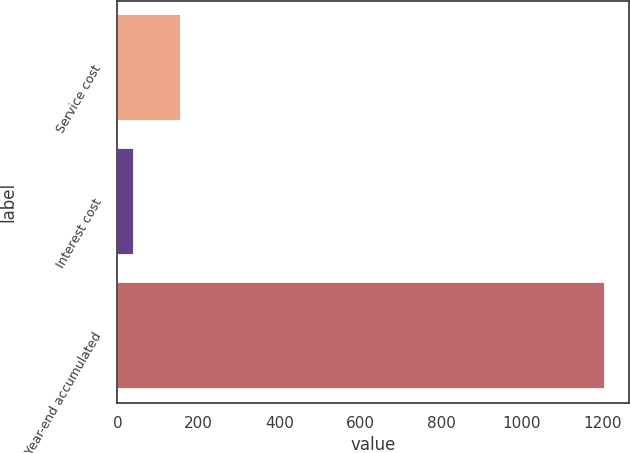Convert chart to OTSL. <chart><loc_0><loc_0><loc_500><loc_500><bar_chart><fcel>Service cost<fcel>Interest cost<fcel>Year-end accumulated<nl><fcel>158.2<fcel>42<fcel>1204<nl></chart> 